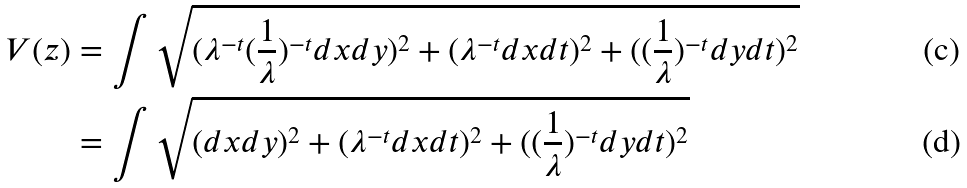Convert formula to latex. <formula><loc_0><loc_0><loc_500><loc_500>V ( z ) & = \int \sqrt { ( \lambda ^ { - t } ( \frac { 1 } { \lambda } ) ^ { - t } d x d y ) ^ { 2 } + ( \lambda ^ { - t } d x d t ) ^ { 2 } + ( ( \frac { 1 } { \lambda } ) ^ { - t } d y d t ) ^ { 2 } } \\ & = \int \sqrt { ( d x d y ) ^ { 2 } + ( \lambda ^ { - t } d x d t ) ^ { 2 } + ( ( \frac { 1 } { \lambda } ) ^ { - t } d y d t ) ^ { 2 } }</formula> 